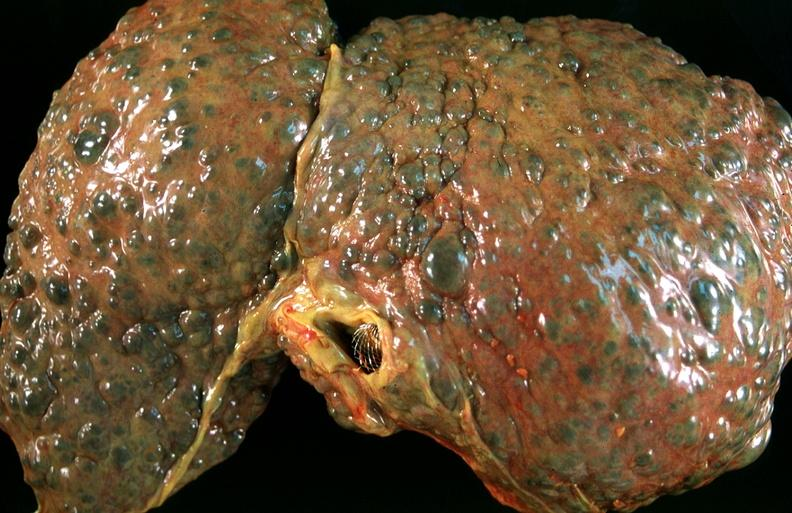what is present?
Answer the question using a single word or phrase. Hepatobiliary 